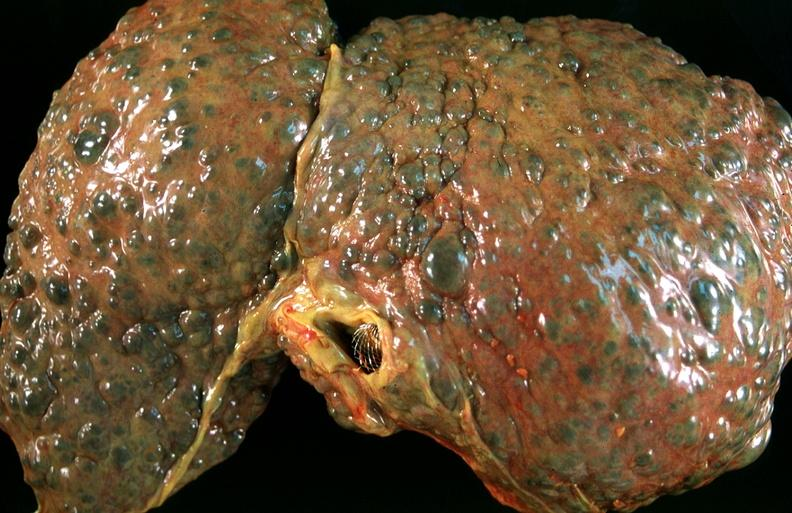what is present?
Answer the question using a single word or phrase. Hepatobiliary 